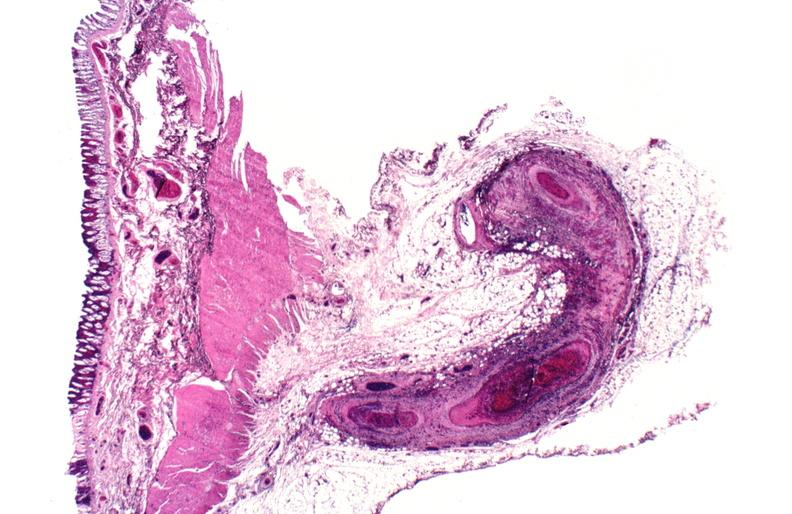what is present?
Answer the question using a single word or phrase. Cardiovascular 